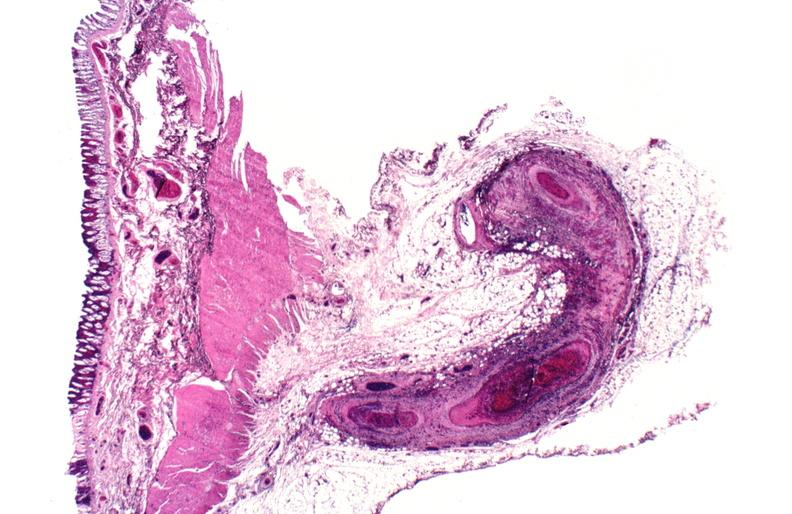what is present?
Answer the question using a single word or phrase. Cardiovascular 